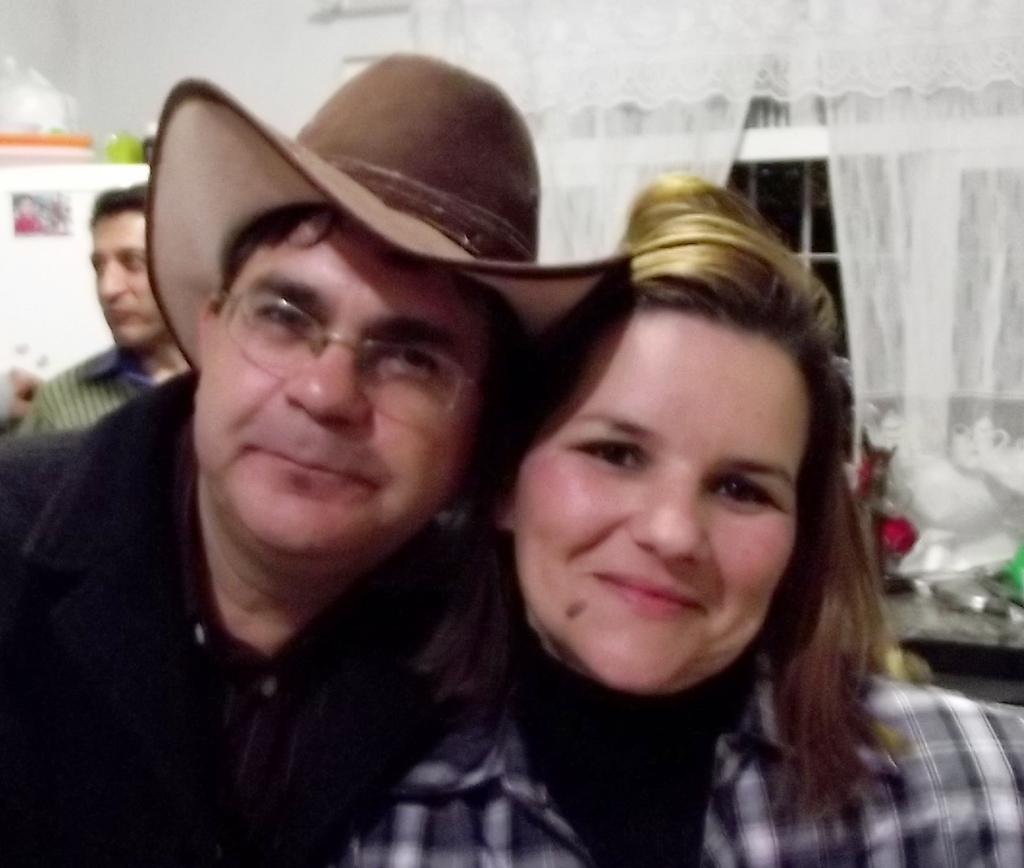Can you describe this image briefly? In this image we can see a few persons, behind them, we can see the white color curtains and a window, on the left side of the image we can see some objects. 